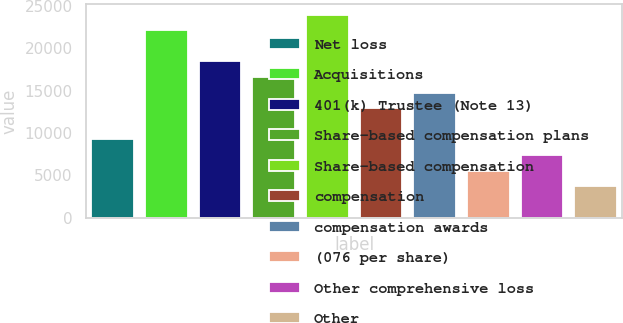Convert chart to OTSL. <chart><loc_0><loc_0><loc_500><loc_500><bar_chart><fcel>Net loss<fcel>Acquisitions<fcel>401(k) Trustee (Note 13)<fcel>Share-based compensation plans<fcel>Share-based compensation<fcel>compensation<fcel>compensation awards<fcel>(076 per share)<fcel>Other comprehensive loss<fcel>Other<nl><fcel>9227.3<fcel>22144.7<fcel>18454<fcel>16608.7<fcel>23990<fcel>12918<fcel>14763.3<fcel>5536.6<fcel>7381.95<fcel>3691.25<nl></chart> 